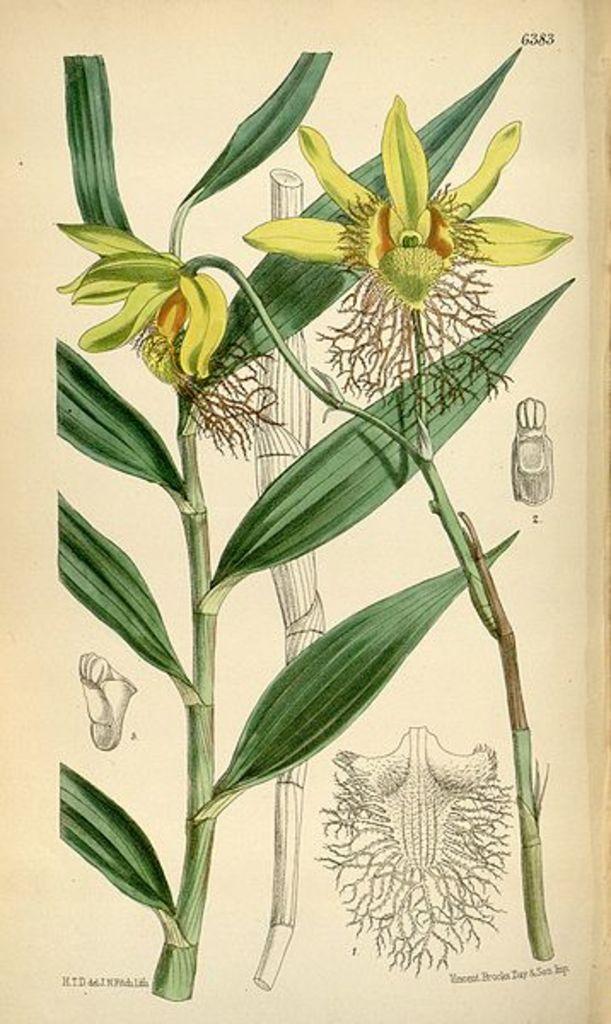Describe this image in one or two sentences. In this image we can see pictures of plants, flowers, roots on the paper, also we can see the text on it. 